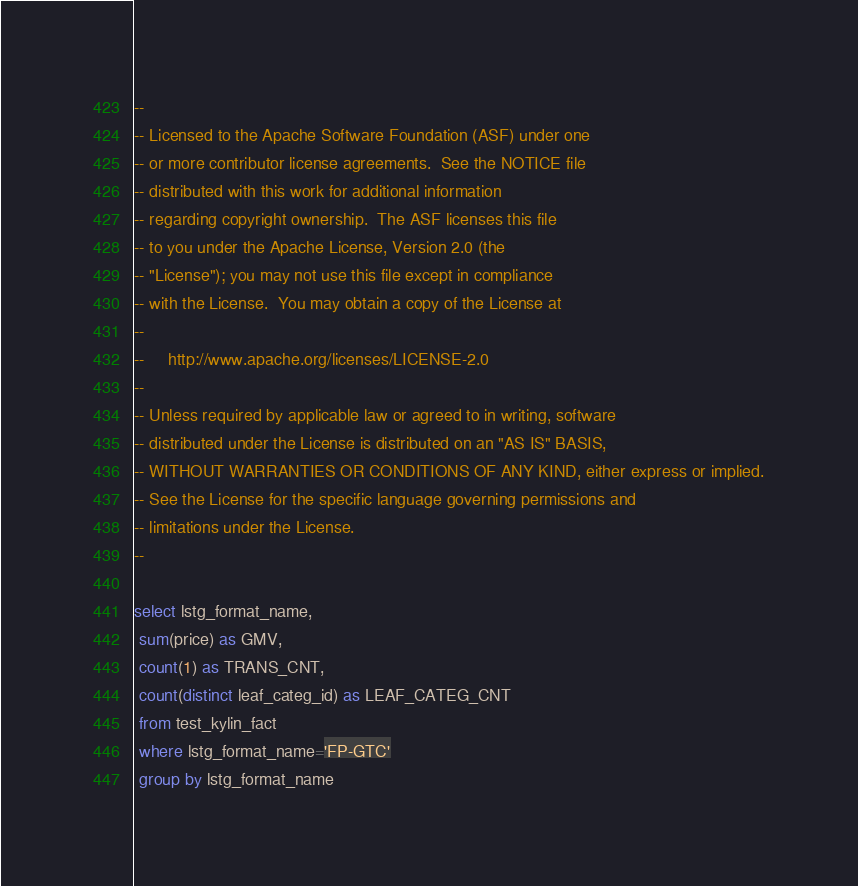Convert code to text. <code><loc_0><loc_0><loc_500><loc_500><_SQL_>--
-- Licensed to the Apache Software Foundation (ASF) under one
-- or more contributor license agreements.  See the NOTICE file
-- distributed with this work for additional information
-- regarding copyright ownership.  The ASF licenses this file
-- to you under the Apache License, Version 2.0 (the
-- "License"); you may not use this file except in compliance
-- with the License.  You may obtain a copy of the License at
--
--     http://www.apache.org/licenses/LICENSE-2.0
--
-- Unless required by applicable law or agreed to in writing, software
-- distributed under the License is distributed on an "AS IS" BASIS,
-- WITHOUT WARRANTIES OR CONDITIONS OF ANY KIND, either express or implied.
-- See the License for the specific language governing permissions and
-- limitations under the License.
--

select lstg_format_name,
 sum(price) as GMV,
 count(1) as TRANS_CNT,
 count(distinct leaf_categ_id) as LEAF_CATEG_CNT
 from test_kylin_fact
 where lstg_format_name='FP-GTC'
 group by lstg_format_name
</code> 